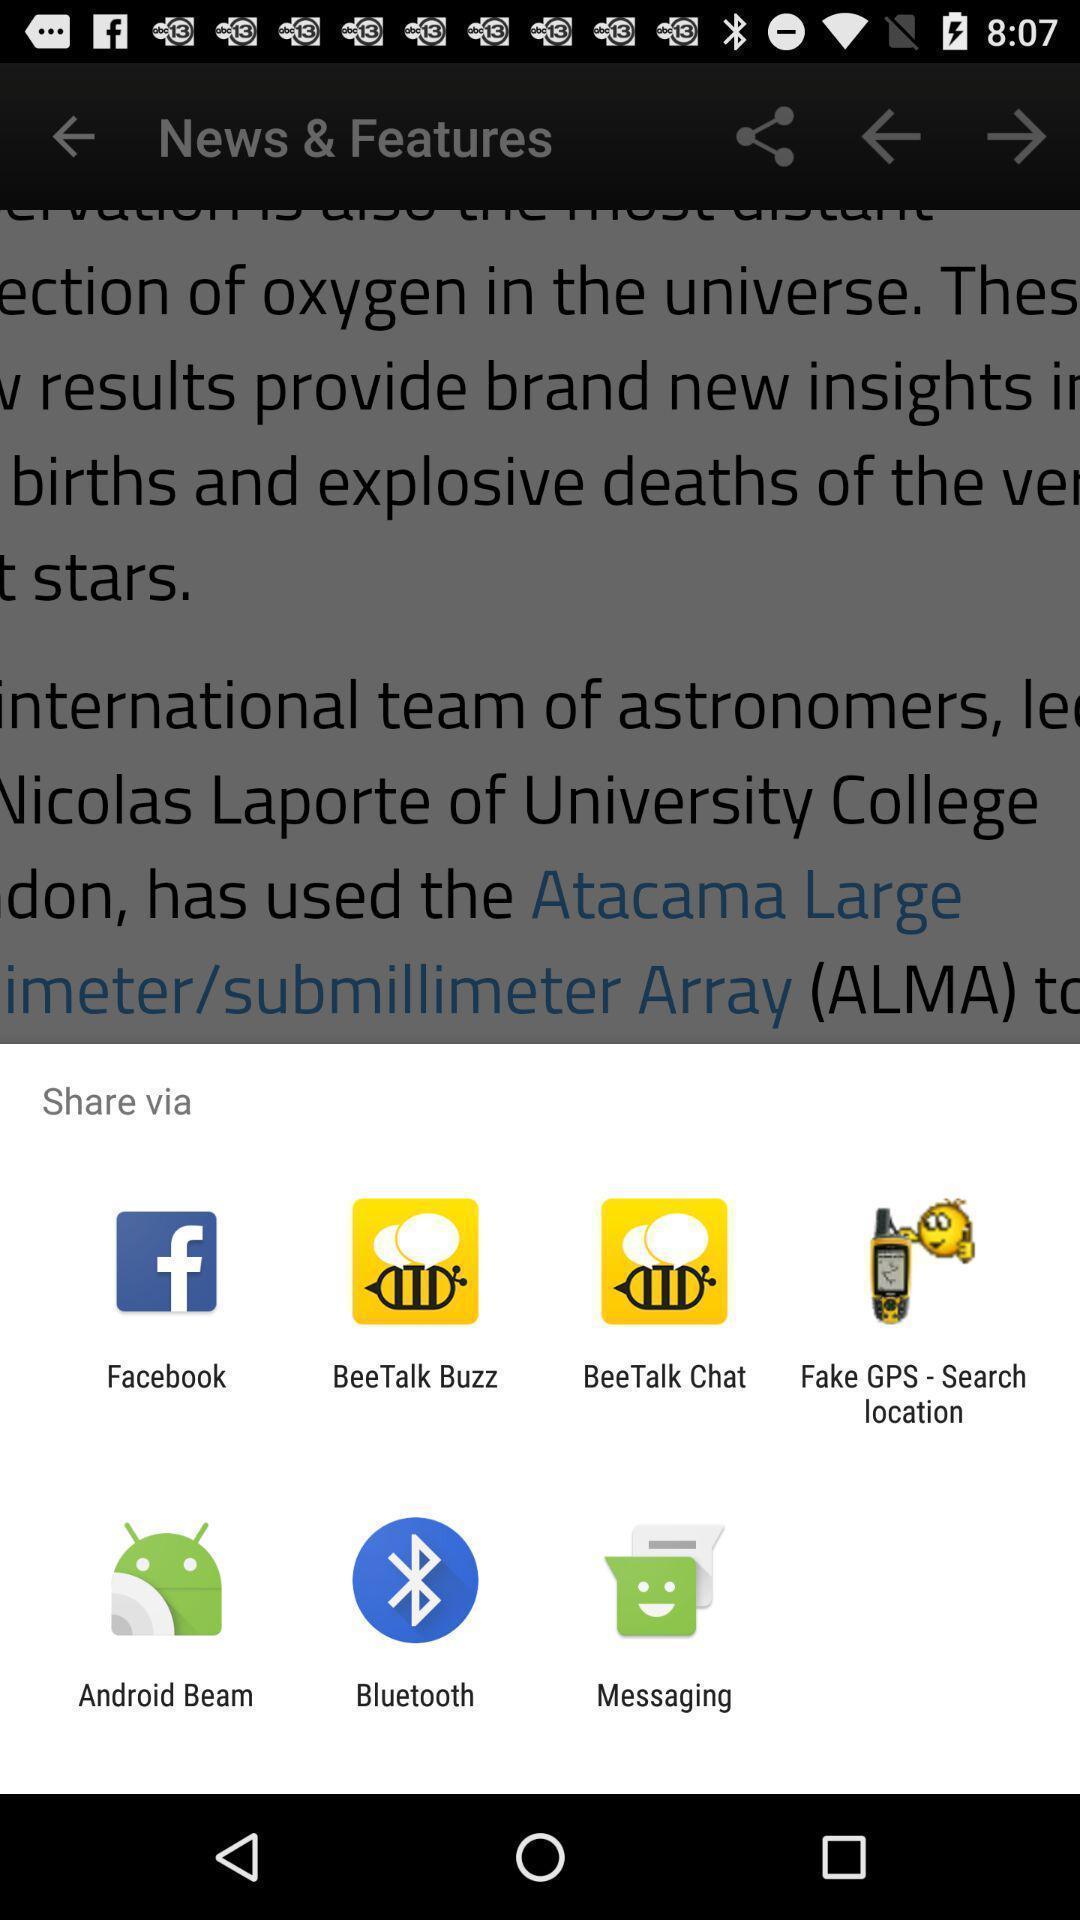Explain what's happening in this screen capture. Push up page showing app preference to share. 